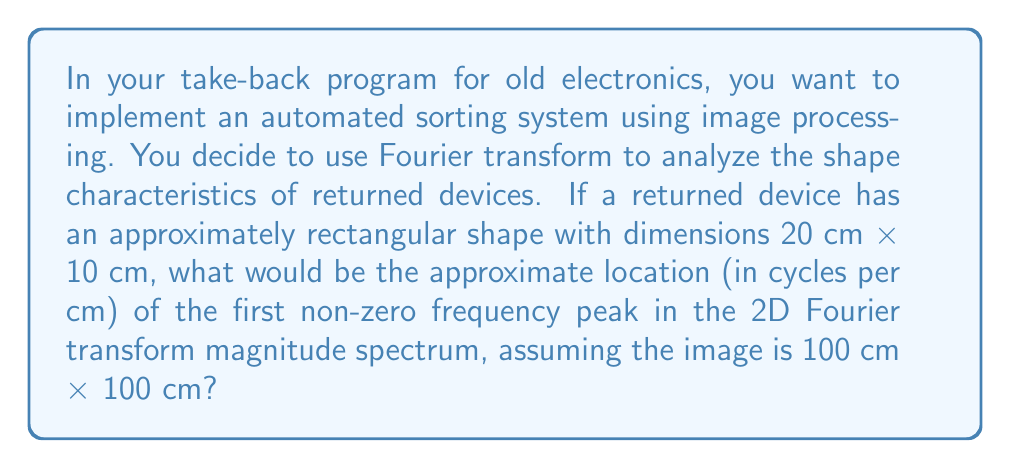Give your solution to this math problem. To solve this problem, we need to understand how the Fourier transform relates to spatial frequencies in an image:

1) The 2D Fourier transform converts an image from the spatial domain to the frequency domain.

2) For a rectangular object in an image, the main frequency components in the Fourier transform will be perpendicular to the object's edges.

3) The spatial frequency $f$ (in cycles per cm) is related to the object's dimension $L$ (in cm) by:

   $$f = \frac{1}{L}$$

4) For our rectangular device:
   - Length: 20 cm, corresponding frequency: $f_L = \frac{1}{20}$ cycles/cm
   - Width: 10 cm, corresponding frequency: $f_W = \frac{1}{10}$ cycles/cm

5) The first non-zero frequency peak will correspond to the larger dimension (lower frequency), which is the length in this case.

6) Therefore, the first non-zero frequency peak will be at approximately $\frac{1}{20}$ cycles/cm.

7) Note that in the Fourier transform, this peak will appear symmetrically on both sides of the origin, at $\pm \frac{1}{20}$ cycles/cm.

8) The exact location might vary slightly due to discretization and edge effects, but $\frac{1}{20}$ cycles/cm is a good approximation.
Answer: The first non-zero frequency peak in the 2D Fourier transform magnitude spectrum will be located at approximately $\pm \frac{1}{20}$ cycles/cm. 